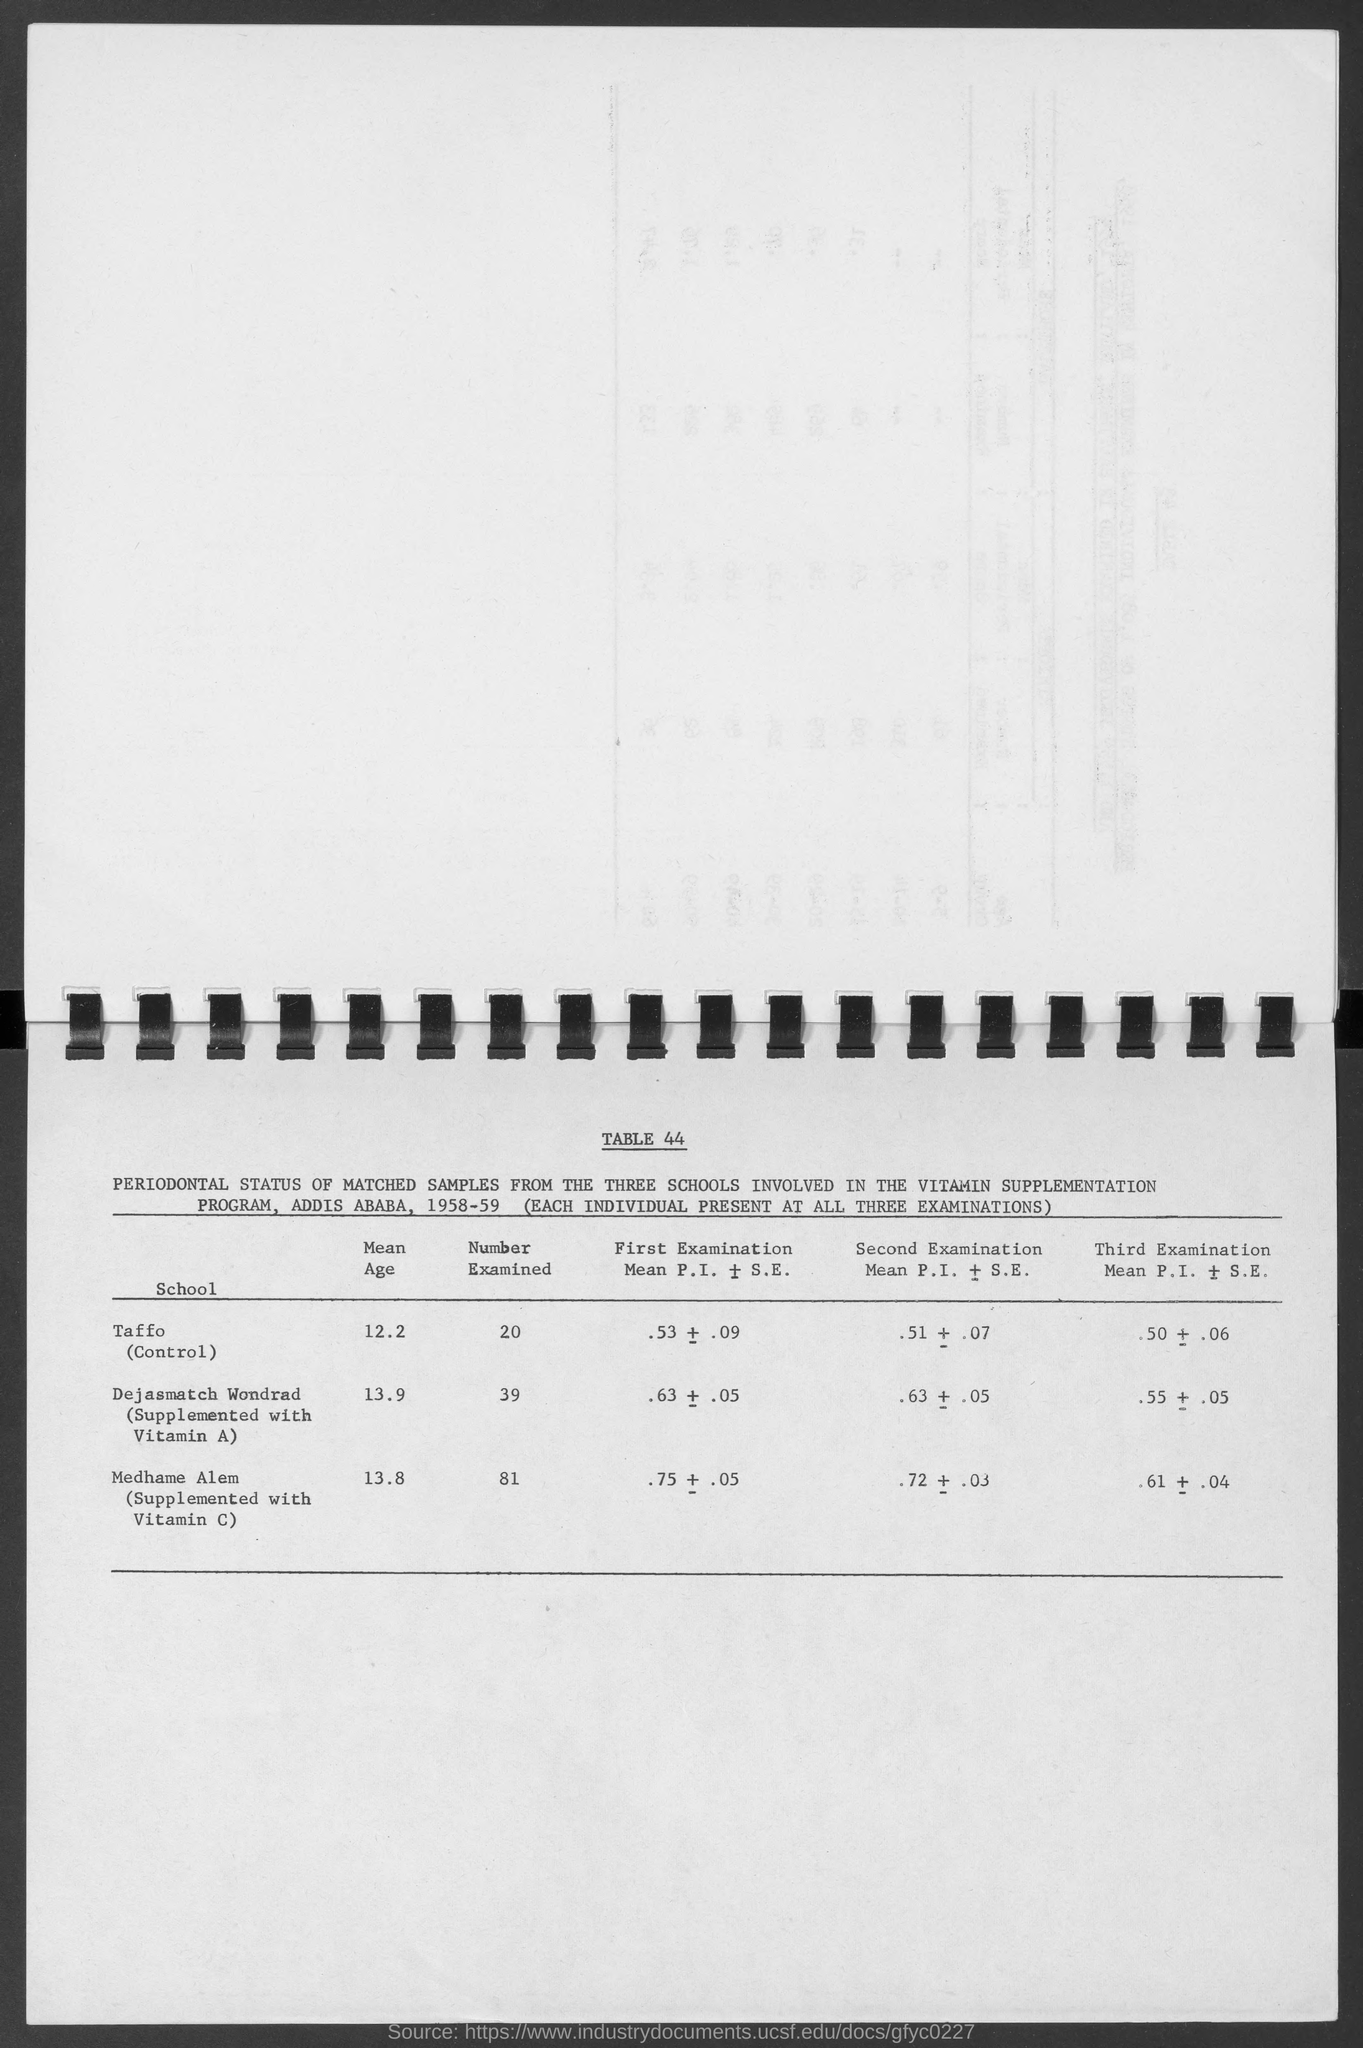What is the Mean Age of the Taffo?
Give a very brief answer. 12.2. How many Schools are Involved in the Vitamin Supplimentation Program?
Your response must be concise. Three schools. 